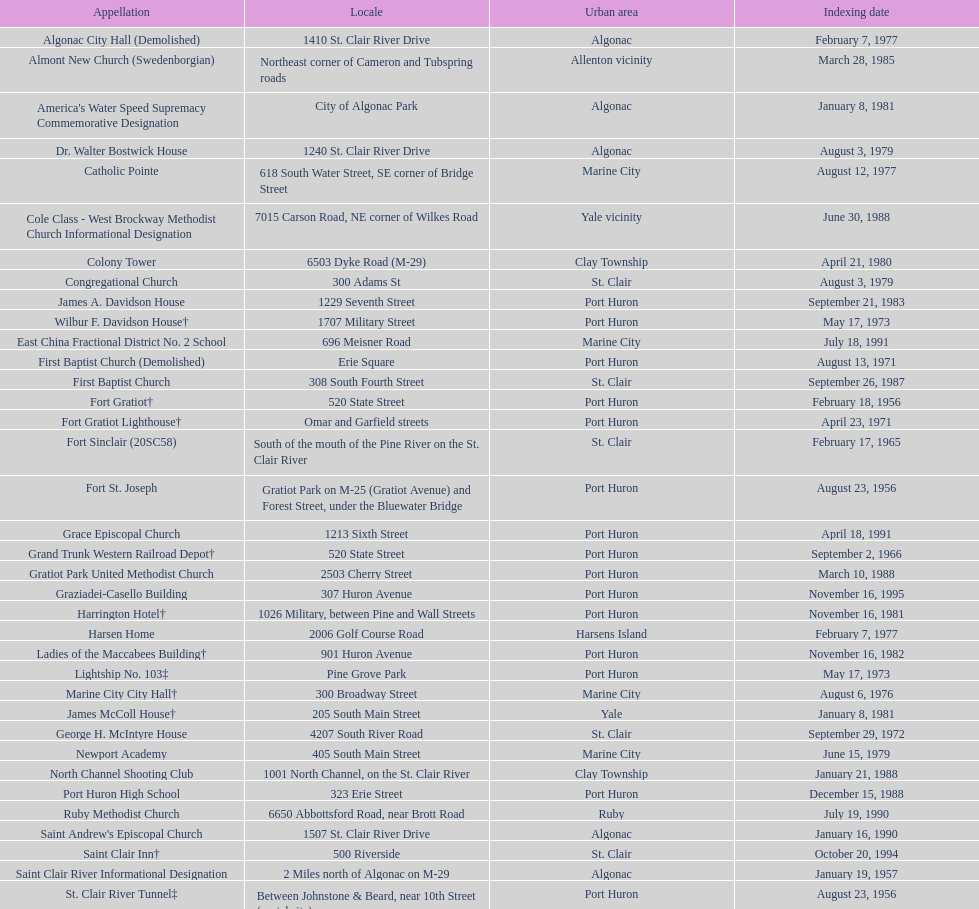Which city is home to the greatest number of historic sites, existing or demolished? Port Huron. 